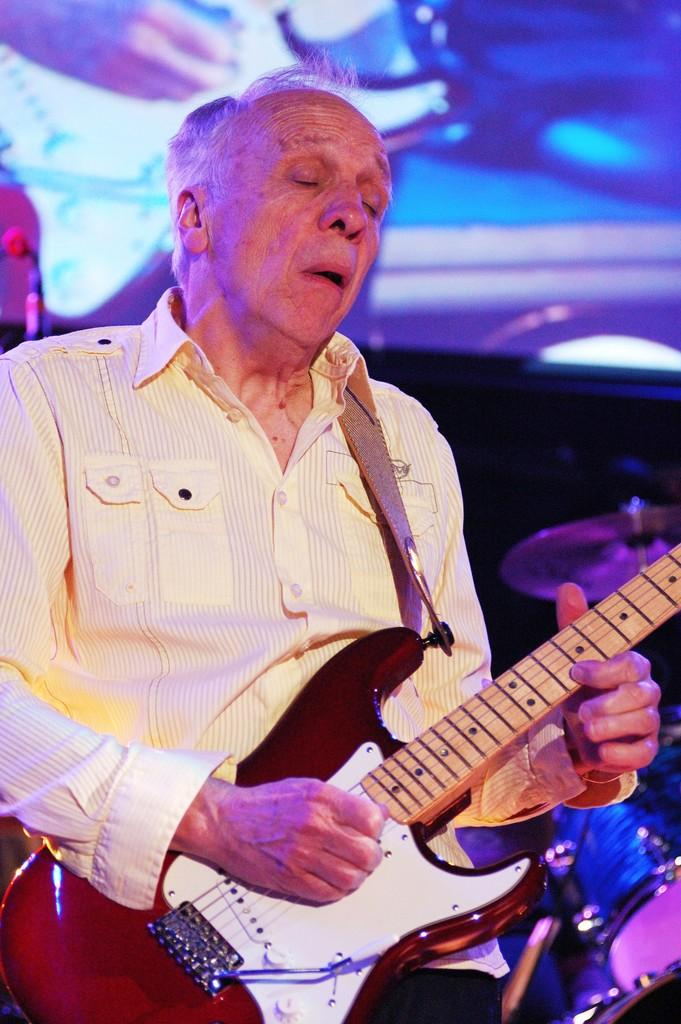Who is present in the image? There is a person in the image. What is the person holding in the image? The person is holding a guitar. What other musical instrument can be seen in the image? There are drums visible in the image. Where are the drums located in relation to the person? The drums are located at the right side of the person. What type of eggs are being cooked in the image? There are no eggs present in the image; it features a person holding a guitar and drums located at the right side of the person. 